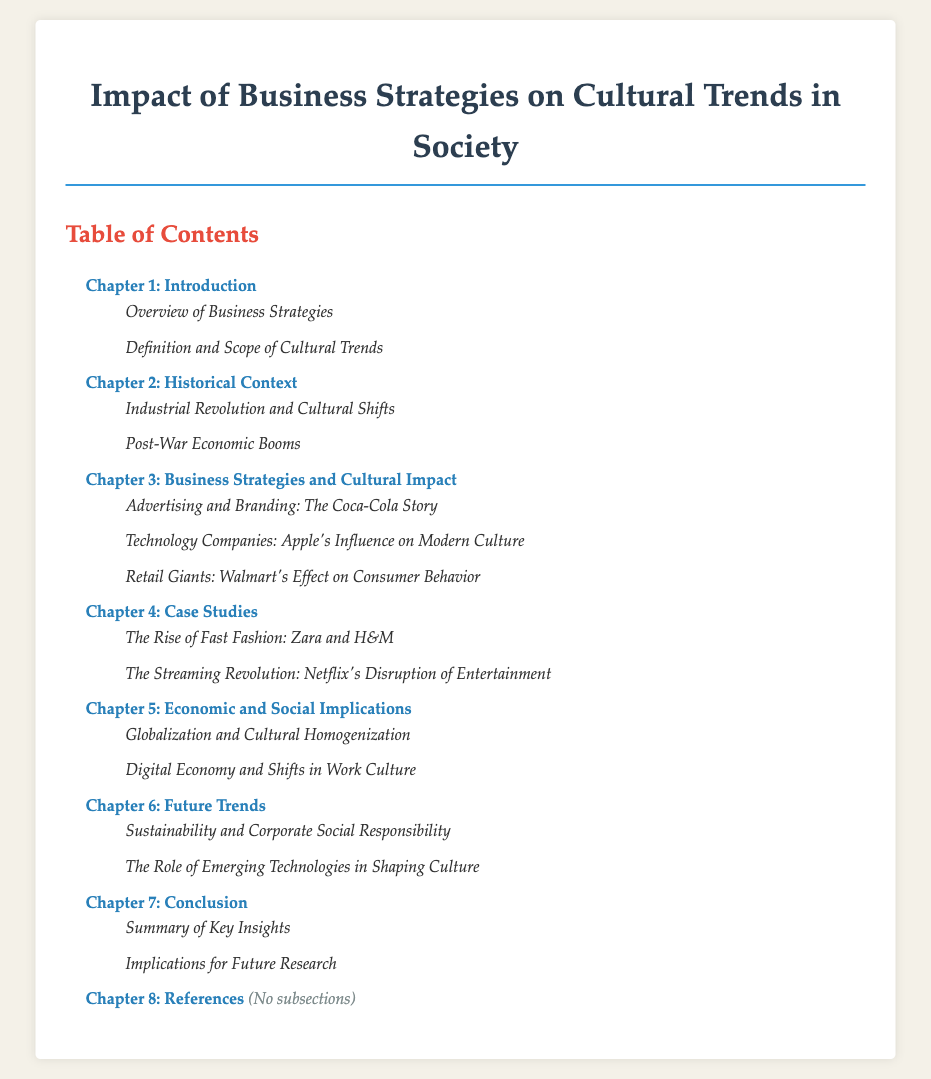What is the title of the document? The title is the main heading of the document, which is stated at the top.
Answer: Impact of Business Strategies on Cultural Trends in Society How many chapters are there in the document? The number of chapters can be counted from the list provided in the Table of Contents.
Answer: 8 What is the focus of Chapter 3? The chapter titles indicate the main theme for that section, which can be inferred from the name.
Answer: Business Strategies and Cultural Impact Which company is discussed in the case study about fast fashion? The specific case study mentioned in Chapter 4 relates to particular companies, which is stated in the subsection.
Answer: Zara and H&M What is one of the implications discussed in Chapter 5? The subsections of the chapter highlight key themes regarding economic and social consequences.
Answer: Globalization and Cultural Homogenization What is the main topic of Chapter 6? The chapter title gives a clear indication of its primary concern, as shown in the Table of Contents.
Answer: Future Trends What type of content does Chapter 8 include? This chapter is noted to have a specific characteristic in the Table of Contents.
Answer: References Which company is highlighted in the subsection about technology influence? It refers to a prominent company that has impacted modern culture, indicated in Chapter 3.
Answer: Apple 